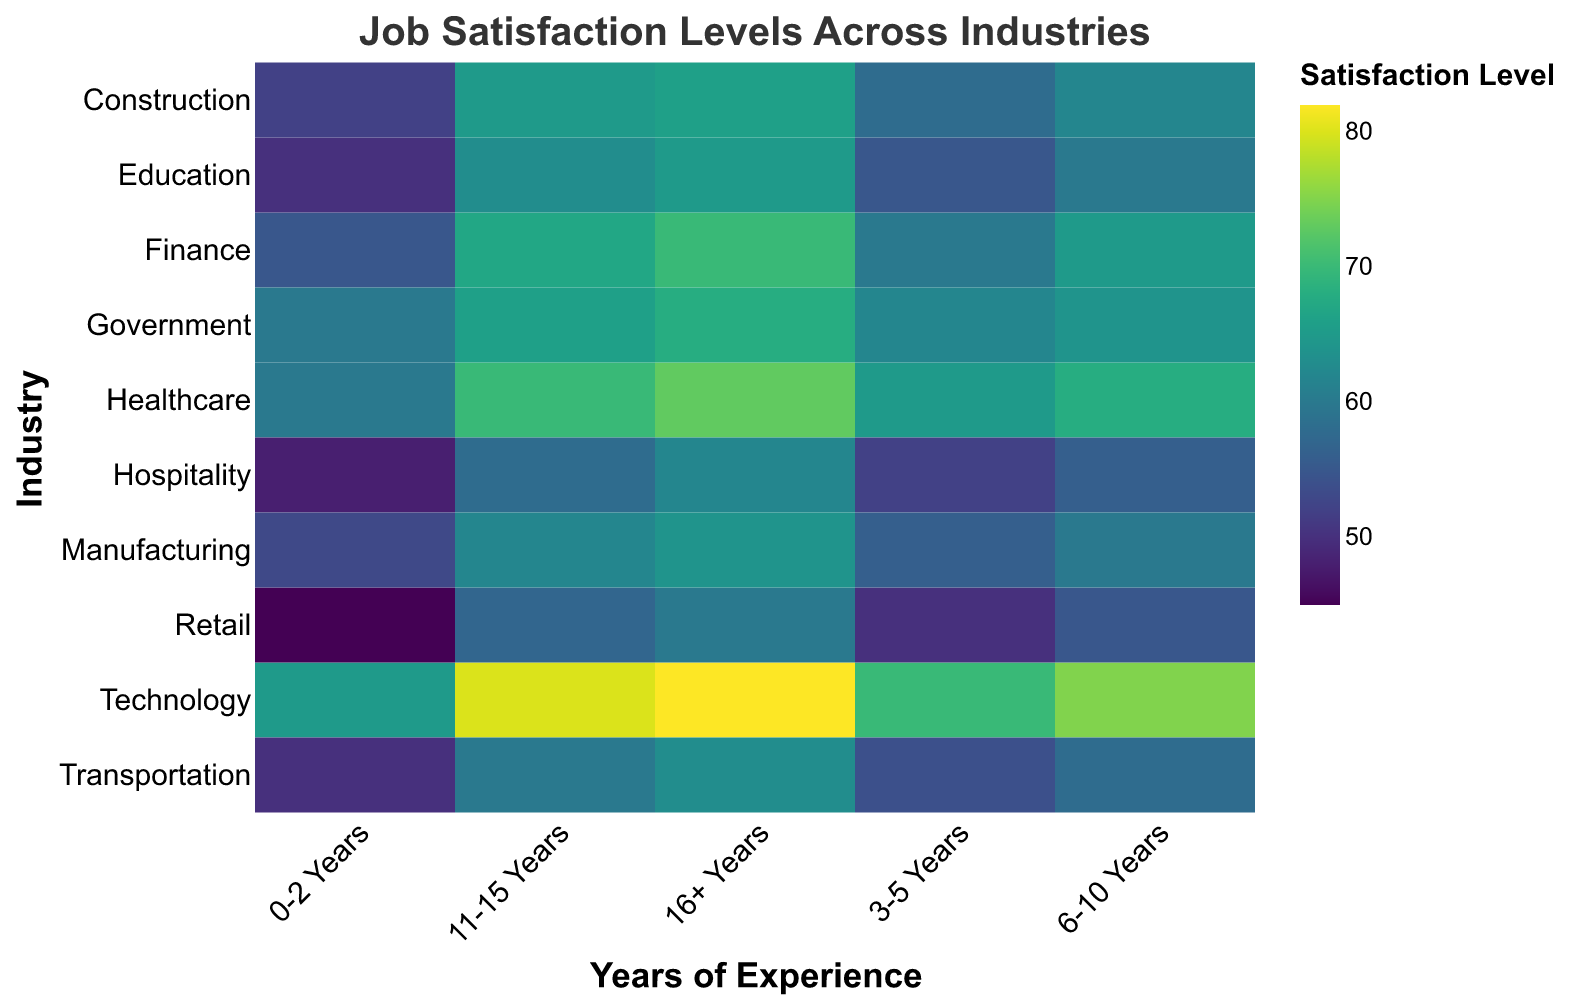What is the job satisfaction level in the Technology industry for employees with 6-10 years of experience? To find this, locate the Technology row and the 6-10 Years column. The value at the intersection is the job satisfaction level.
Answer: 75 Which industry has the highest job satisfaction level for employees with 3-5 years of experience? Scan the 3-5 Years column to find the highest value. The highest value in this column is in the Technology industry.
Answer: Technology What is the difference in job satisfaction levels between employees with 0-2 years and 16+ years of experience in the Retail industry? Identify the satisfaction values for the Retail industry at 0-2 Years and 16+ Years. Subtract the former from the latter: 60 - 45.
Answer: 15 In which industry does job satisfaction see the largest increase from 0-2 years to 11-15 years? Calculate the difference for each industry from 0-2 years to 11-15 years and compare. For Technology: 80 - 65 = 15, for Healthcare: 70 - 60 = 10. Do this for all industries; Technology shows the largest increase.
Answer: Technology What is the average job satisfaction level for government industry employees across all years of experience? Add the satisfaction levels for Government industry across all experience years and divide by the number of years: (60 + 62 + 64 + 66 + 68) / 5.
Answer: 64 How does the job satisfaction of technology professionals with 16+ years compare to professionals in manufacturing with the same experience? Check the satisfaction values for both Technology and Manufacturing at 16+ Years. Technology has 82, and Manufacturing has 64.
Answer: Technology professionals have higher satisfaction Which industry has the lowest initial job satisfaction level for employees with 0-2 years of experience? Look at the 0-2 Years column and find the smallest value. The lowest value is in the Retail industry.
Answer: Retail Does job satisfaction in the Healthcare industry consistently increase with years of experience? Observe the values for the Healthcare industry to see if they rise sequentially with each subsequent experience category. They do: 60, 65, 68, 70, and 73.
Answer: Yes What is the median job satisfaction level for the Transportation industry across all years of experience? List the satisfaction levels for Transportation: 50, 54, 58, 60, 63. Find the middle value.
Answer: 58 Which industries have a job satisfaction level of 60 for employees with 0-2 years of experience? Look at the 0-2 years column and find all instances of the value 60. The industries are Healthcare and Government.
Answer: Healthcare and Government 